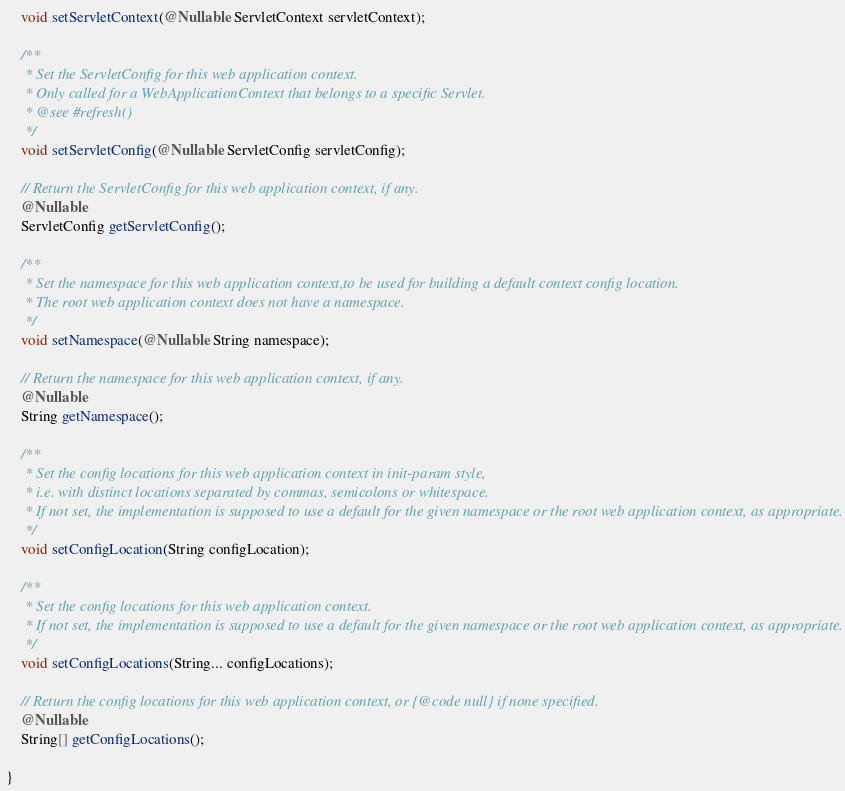Convert code to text. <code><loc_0><loc_0><loc_500><loc_500><_Java_>	void setServletContext(@Nullable ServletContext servletContext);

	/**
	 * Set the ServletConfig for this web application context.
	 * Only called for a WebApplicationContext that belongs to a specific Servlet.
	 * @see #refresh()
	 */
	void setServletConfig(@Nullable ServletConfig servletConfig);

	// Return the ServletConfig for this web application context, if any.
	@Nullable
	ServletConfig getServletConfig();

	/**
	 * Set the namespace for this web application context,to be used for building a default context config location.
	 * The root web application context does not have a namespace.
	 */
	void setNamespace(@Nullable String namespace);

	// Return the namespace for this web application context, if any.
	@Nullable
	String getNamespace();

	/**
	 * Set the config locations for this web application context in init-param style,
	 * i.e. with distinct locations separated by commas, semicolons or whitespace.
	 * If not set, the implementation is supposed to use a default for the given namespace or the root web application context, as appropriate.
	 */
	void setConfigLocation(String configLocation);

	/**
	 * Set the config locations for this web application context.
	 * If not set, the implementation is supposed to use a default for the given namespace or the root web application context, as appropriate.
	 */
	void setConfigLocations(String... configLocations);

	// Return the config locations for this web application context, or {@code null} if none specified.
	@Nullable
	String[] getConfigLocations();

}
</code> 